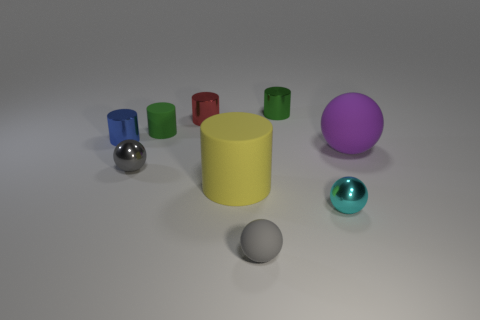Can you tell me which objects in this image are made of metal? Certainly! In this image, the small shiny silver sphere to the left and the small red object that resembles a canister appear to be made of metal. 